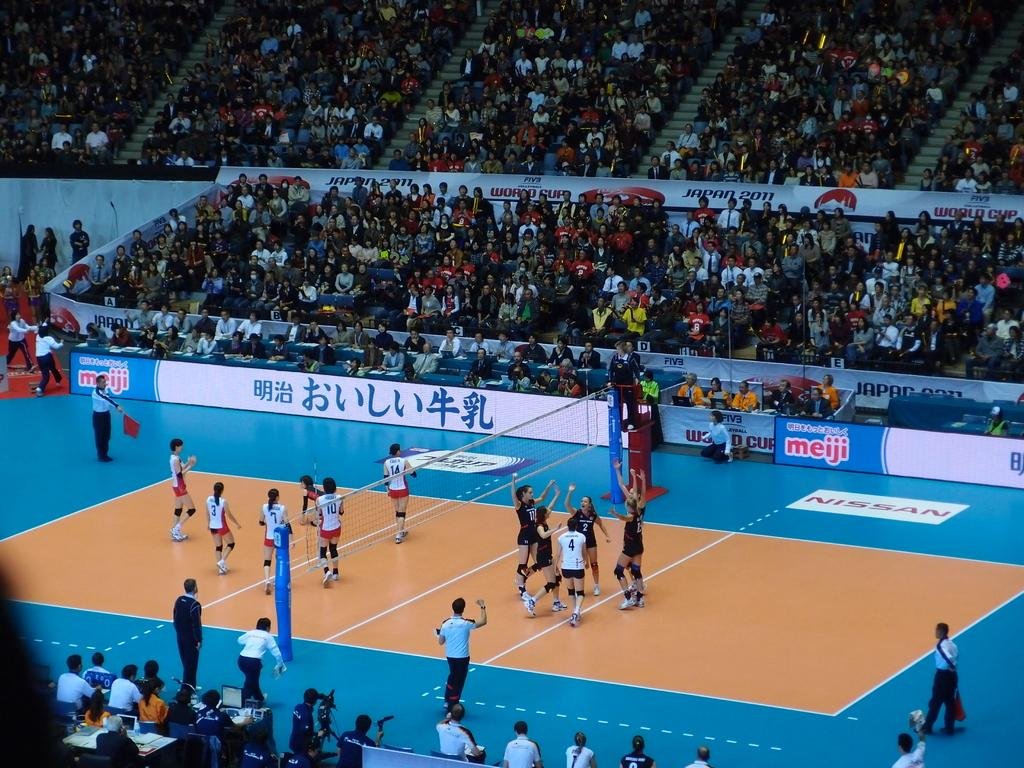Provide a one-sentence caption for the provided image. A meiji logo can be seen on a basketball court. 